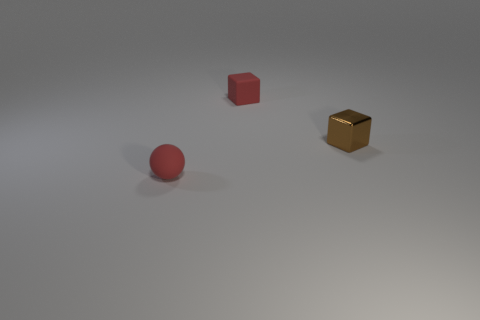Add 3 big green rubber blocks. How many objects exist? 6 Subtract all cubes. How many objects are left? 1 Add 3 small brown metal cubes. How many small brown metal cubes are left? 4 Add 3 small purple metallic cubes. How many small purple metallic cubes exist? 3 Subtract 0 brown cylinders. How many objects are left? 3 Subtract all red matte spheres. Subtract all big cyan metal objects. How many objects are left? 2 